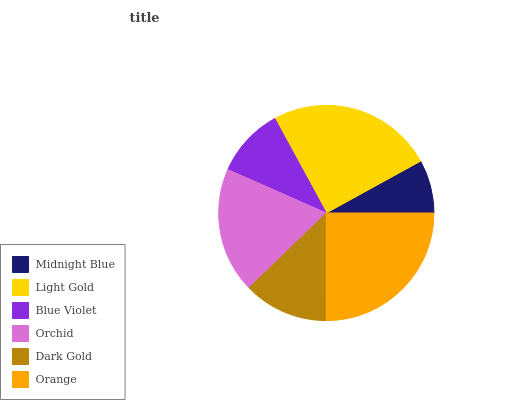Is Midnight Blue the minimum?
Answer yes or no. Yes. Is Orange the maximum?
Answer yes or no. Yes. Is Light Gold the minimum?
Answer yes or no. No. Is Light Gold the maximum?
Answer yes or no. No. Is Light Gold greater than Midnight Blue?
Answer yes or no. Yes. Is Midnight Blue less than Light Gold?
Answer yes or no. Yes. Is Midnight Blue greater than Light Gold?
Answer yes or no. No. Is Light Gold less than Midnight Blue?
Answer yes or no. No. Is Orchid the high median?
Answer yes or no. Yes. Is Dark Gold the low median?
Answer yes or no. Yes. Is Light Gold the high median?
Answer yes or no. No. Is Orchid the low median?
Answer yes or no. No. 